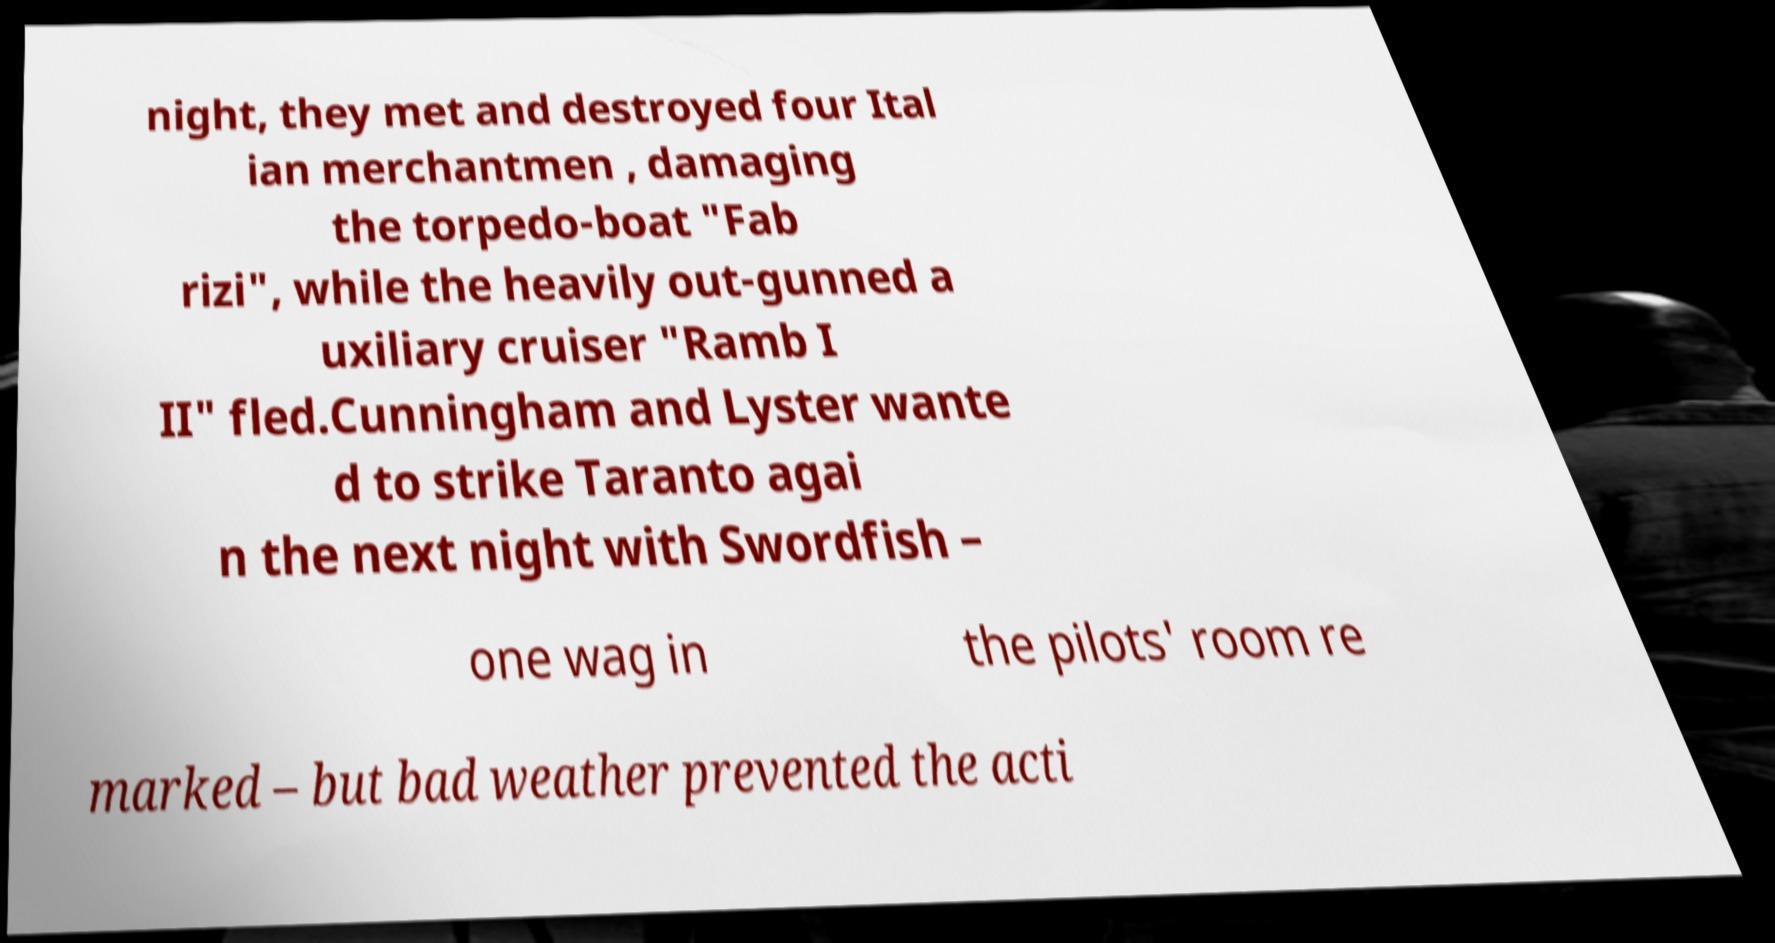Please identify and transcribe the text found in this image. night, they met and destroyed four Ital ian merchantmen , damaging the torpedo-boat "Fab rizi", while the heavily out-gunned a uxiliary cruiser "Ramb I II" fled.Cunningham and Lyster wante d to strike Taranto agai n the next night with Swordfish – one wag in the pilots' room re marked – but bad weather prevented the acti 